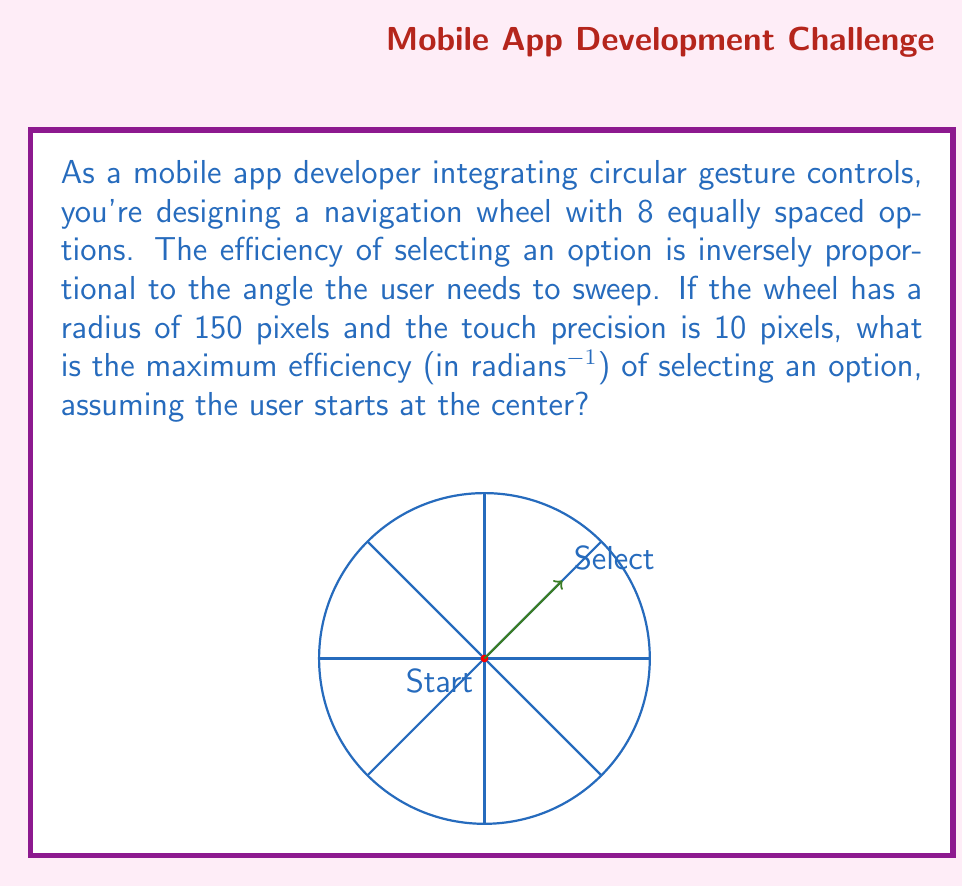Help me with this question. Let's approach this step-by-step:

1) First, we need to calculate the angle subtended by each option. Since there are 8 options equally spaced, each option occupies:

   $$\theta = \frac{2\pi}{8} = \frac{\pi}{4}$$ radians

2) The efficiency is inversely proportional to the angle swept. The maximum efficiency will occur when the user selects the closest option, which requires sweeping half of this angle:

   $$\theta_{min} = \frac{\theta}{2} = \frac{\pi}{8}$$ radians

3) However, we need to consider the touch precision. The user's finger covers an area, not a point. With a precision of 10 pixels and a radius of 150 pixels, we can calculate the angle this precision represents:

   $$\theta_{precision} = \arcsin(\frac{10}{150}) \approx 0.0667$$ radians

4) The total minimum angle the user needs to sweep is:

   $$\theta_{total} = \theta_{min} + \theta_{precision} = \frac{\pi}{8} + 0.0667 \approx 0.4605$$ radians

5) Since efficiency is inversely proportional to this angle, we can express it as:

   $$Efficiency = \frac{1}{\theta_{total}}$$

6) Therefore, the maximum efficiency is:

   $$Efficiency_{max} = \frac{1}{0.4605} \approx 2.1715$$ radians^-1
Answer: $2.1715$ radians^-1 